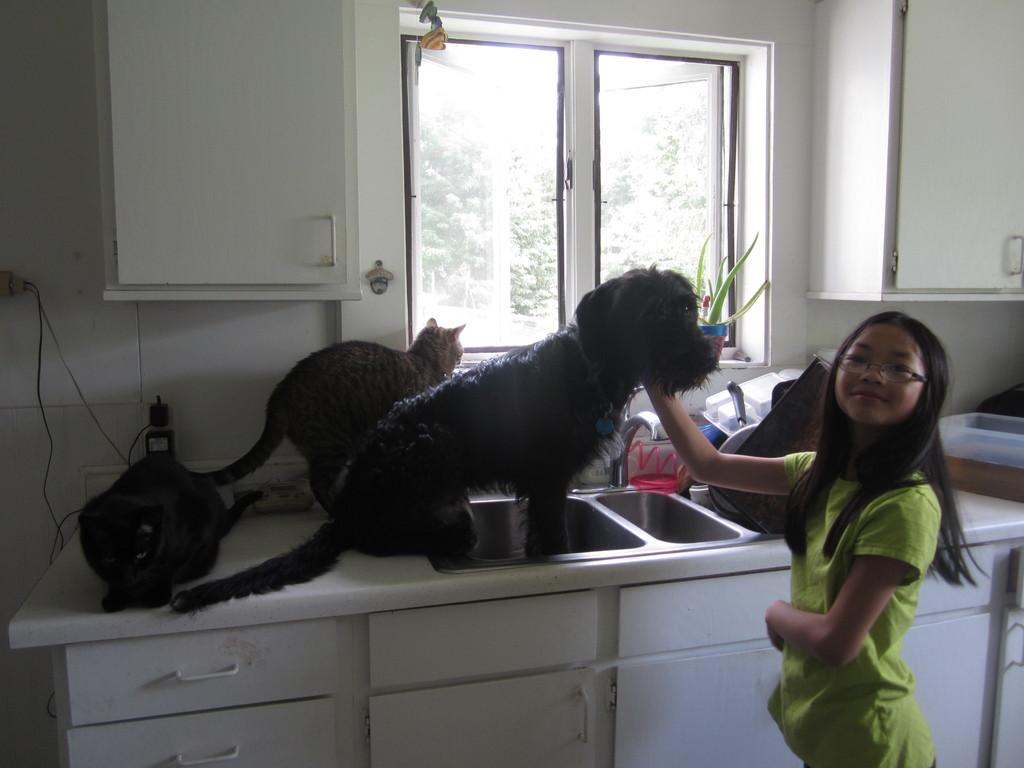Who is present in the image? There is a girl in the image. What is the girl doing in the image? The girl is caressing a dog. Are there any other animals in the image besides the dog? Yes, there are two cats in the image. Where are the cats located in the image? The cats are on a kitchen table. What type of zoo can be seen in the background of the image? There is no zoo present in the image; it features a girl, a dog, and two cats. Are there any slaves depicted in the image? There is no depiction of slavery or slaves in the image. 